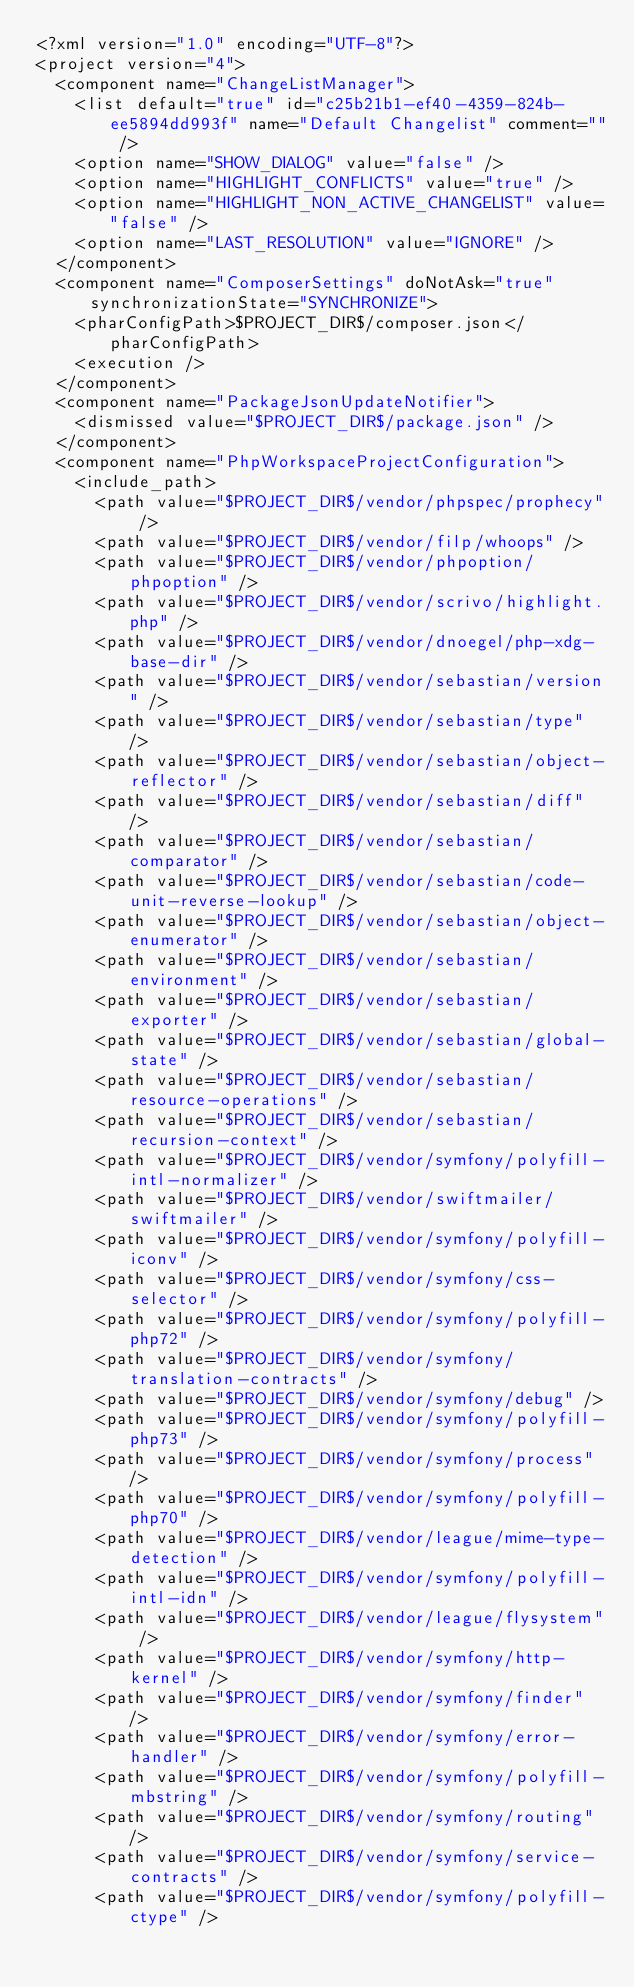Convert code to text. <code><loc_0><loc_0><loc_500><loc_500><_XML_><?xml version="1.0" encoding="UTF-8"?>
<project version="4">
  <component name="ChangeListManager">
    <list default="true" id="c25b21b1-ef40-4359-824b-ee5894dd993f" name="Default Changelist" comment="" />
    <option name="SHOW_DIALOG" value="false" />
    <option name="HIGHLIGHT_CONFLICTS" value="true" />
    <option name="HIGHLIGHT_NON_ACTIVE_CHANGELIST" value="false" />
    <option name="LAST_RESOLUTION" value="IGNORE" />
  </component>
  <component name="ComposerSettings" doNotAsk="true" synchronizationState="SYNCHRONIZE">
    <pharConfigPath>$PROJECT_DIR$/composer.json</pharConfigPath>
    <execution />
  </component>
  <component name="PackageJsonUpdateNotifier">
    <dismissed value="$PROJECT_DIR$/package.json" />
  </component>
  <component name="PhpWorkspaceProjectConfiguration">
    <include_path>
      <path value="$PROJECT_DIR$/vendor/phpspec/prophecy" />
      <path value="$PROJECT_DIR$/vendor/filp/whoops" />
      <path value="$PROJECT_DIR$/vendor/phpoption/phpoption" />
      <path value="$PROJECT_DIR$/vendor/scrivo/highlight.php" />
      <path value="$PROJECT_DIR$/vendor/dnoegel/php-xdg-base-dir" />
      <path value="$PROJECT_DIR$/vendor/sebastian/version" />
      <path value="$PROJECT_DIR$/vendor/sebastian/type" />
      <path value="$PROJECT_DIR$/vendor/sebastian/object-reflector" />
      <path value="$PROJECT_DIR$/vendor/sebastian/diff" />
      <path value="$PROJECT_DIR$/vendor/sebastian/comparator" />
      <path value="$PROJECT_DIR$/vendor/sebastian/code-unit-reverse-lookup" />
      <path value="$PROJECT_DIR$/vendor/sebastian/object-enumerator" />
      <path value="$PROJECT_DIR$/vendor/sebastian/environment" />
      <path value="$PROJECT_DIR$/vendor/sebastian/exporter" />
      <path value="$PROJECT_DIR$/vendor/sebastian/global-state" />
      <path value="$PROJECT_DIR$/vendor/sebastian/resource-operations" />
      <path value="$PROJECT_DIR$/vendor/sebastian/recursion-context" />
      <path value="$PROJECT_DIR$/vendor/symfony/polyfill-intl-normalizer" />
      <path value="$PROJECT_DIR$/vendor/swiftmailer/swiftmailer" />
      <path value="$PROJECT_DIR$/vendor/symfony/polyfill-iconv" />
      <path value="$PROJECT_DIR$/vendor/symfony/css-selector" />
      <path value="$PROJECT_DIR$/vendor/symfony/polyfill-php72" />
      <path value="$PROJECT_DIR$/vendor/symfony/translation-contracts" />
      <path value="$PROJECT_DIR$/vendor/symfony/debug" />
      <path value="$PROJECT_DIR$/vendor/symfony/polyfill-php73" />
      <path value="$PROJECT_DIR$/vendor/symfony/process" />
      <path value="$PROJECT_DIR$/vendor/symfony/polyfill-php70" />
      <path value="$PROJECT_DIR$/vendor/league/mime-type-detection" />
      <path value="$PROJECT_DIR$/vendor/symfony/polyfill-intl-idn" />
      <path value="$PROJECT_DIR$/vendor/league/flysystem" />
      <path value="$PROJECT_DIR$/vendor/symfony/http-kernel" />
      <path value="$PROJECT_DIR$/vendor/symfony/finder" />
      <path value="$PROJECT_DIR$/vendor/symfony/error-handler" />
      <path value="$PROJECT_DIR$/vendor/symfony/polyfill-mbstring" />
      <path value="$PROJECT_DIR$/vendor/symfony/routing" />
      <path value="$PROJECT_DIR$/vendor/symfony/service-contracts" />
      <path value="$PROJECT_DIR$/vendor/symfony/polyfill-ctype" /></code> 